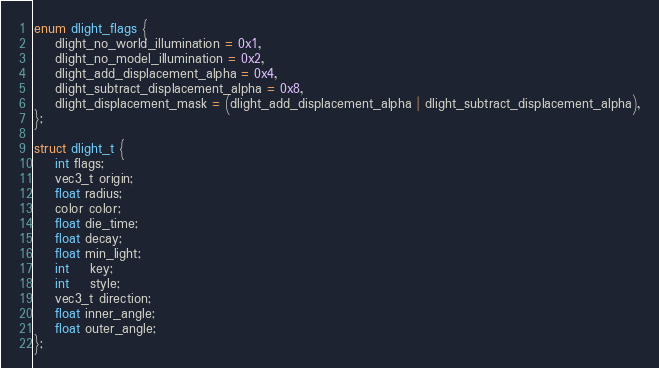Convert code to text. <code><loc_0><loc_0><loc_500><loc_500><_C++_>enum dlight_flags {
	dlight_no_world_illumination = 0x1,
	dlight_no_model_illumination = 0x2,
	dlight_add_displacement_alpha = 0x4,
	dlight_subtract_displacement_alpha = 0x8,
	dlight_displacement_mask = (dlight_add_displacement_alpha | dlight_subtract_displacement_alpha),
};

struct dlight_t {
	int flags;
	vec3_t origin;
	float radius;
	color color;
	float die_time;
	float decay;
	float min_light;
	int	key;
	int	style;
	vec3_t direction;
	float inner_angle;
	float outer_angle;
};</code> 